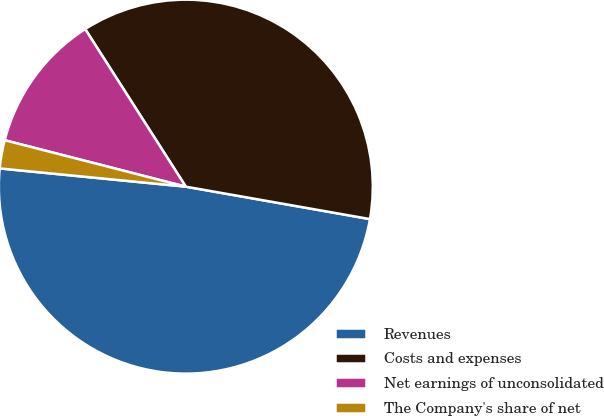Convert chart. <chart><loc_0><loc_0><loc_500><loc_500><pie_chart><fcel>Revenues<fcel>Costs and expenses<fcel>Net earnings of unconsolidated<fcel>The Company's share of net<nl><fcel>48.78%<fcel>36.82%<fcel>11.96%<fcel>2.44%<nl></chart> 